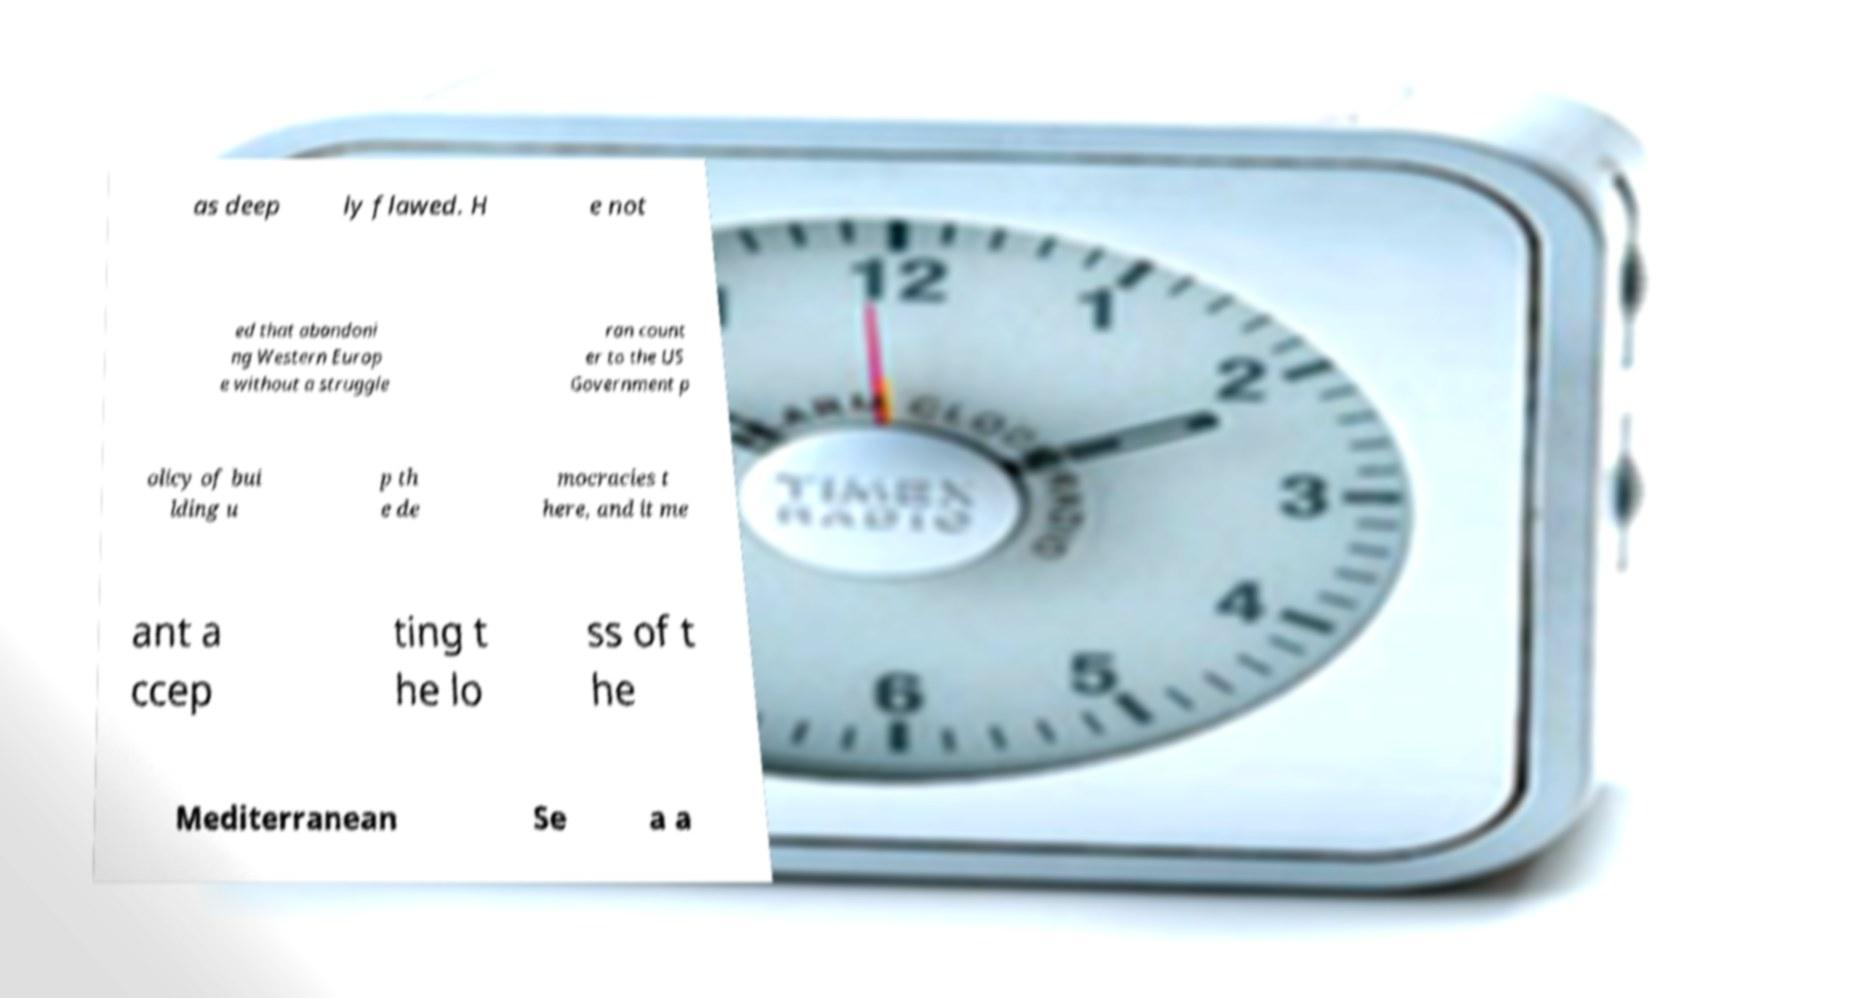There's text embedded in this image that I need extracted. Can you transcribe it verbatim? as deep ly flawed. H e not ed that abandoni ng Western Europ e without a struggle ran count er to the US Government p olicy of bui lding u p th e de mocracies t here, and it me ant a ccep ting t he lo ss of t he Mediterranean Se a a 